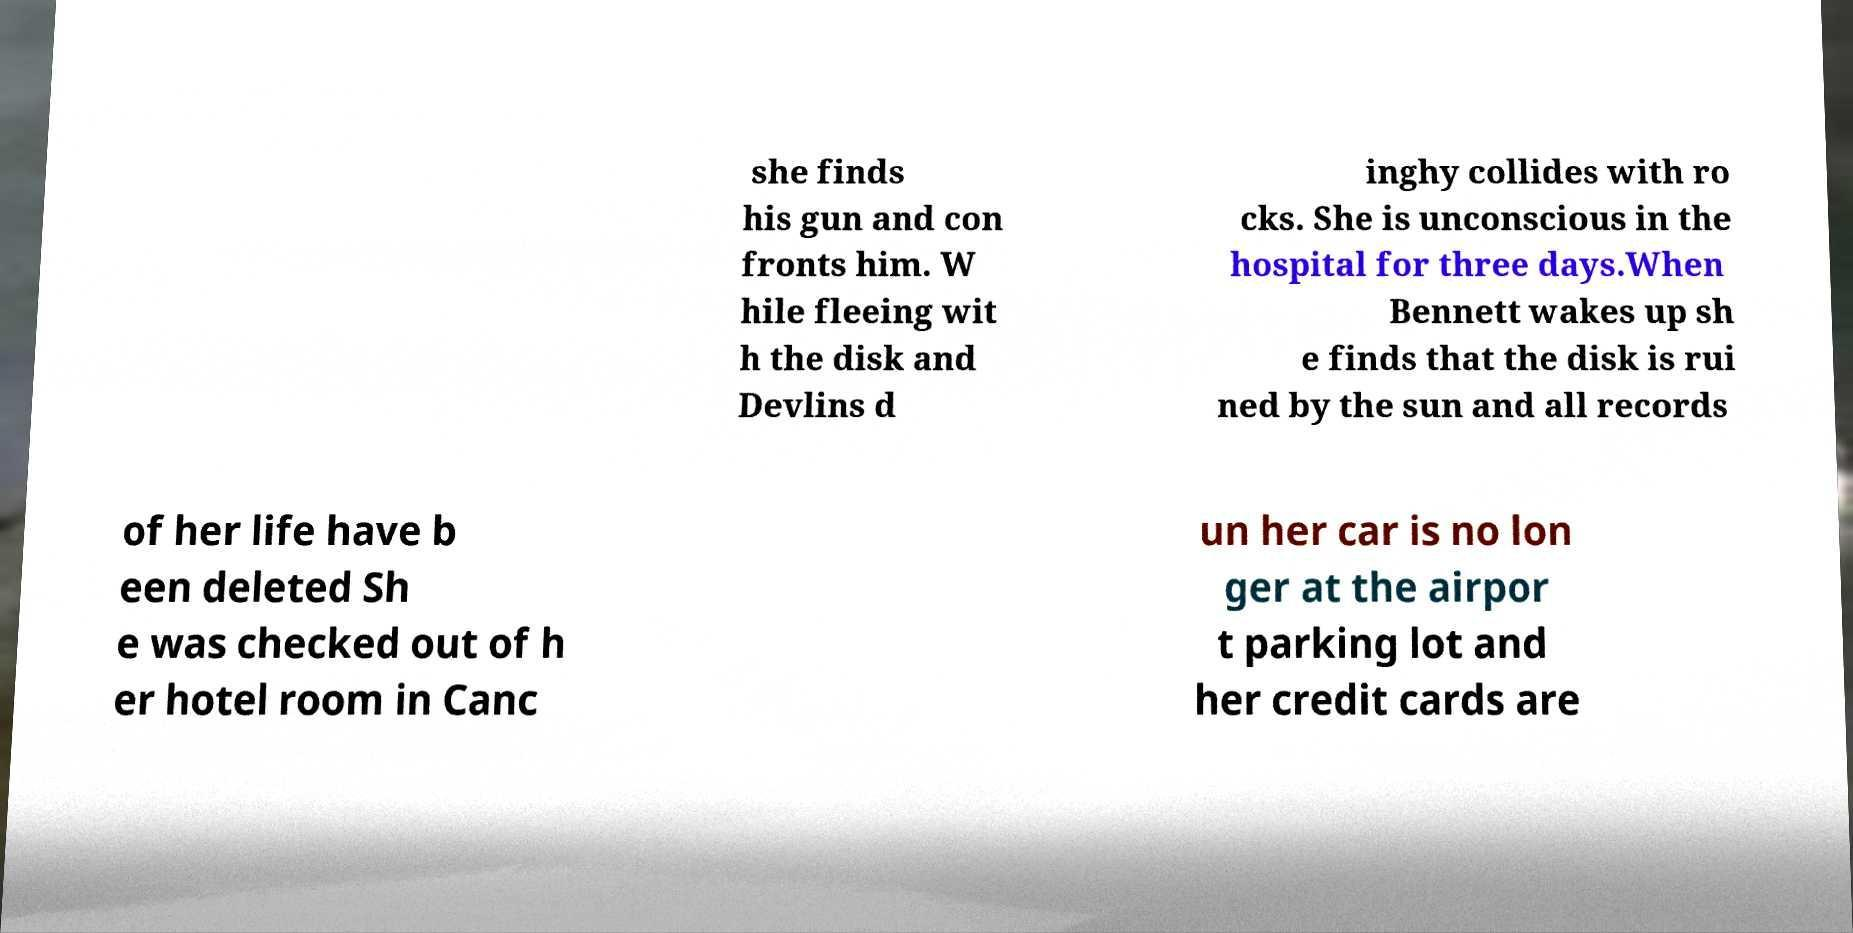Please identify and transcribe the text found in this image. she finds his gun and con fronts him. W hile fleeing wit h the disk and Devlins d inghy collides with ro cks. She is unconscious in the hospital for three days.When Bennett wakes up sh e finds that the disk is rui ned by the sun and all records of her life have b een deleted Sh e was checked out of h er hotel room in Canc un her car is no lon ger at the airpor t parking lot and her credit cards are 